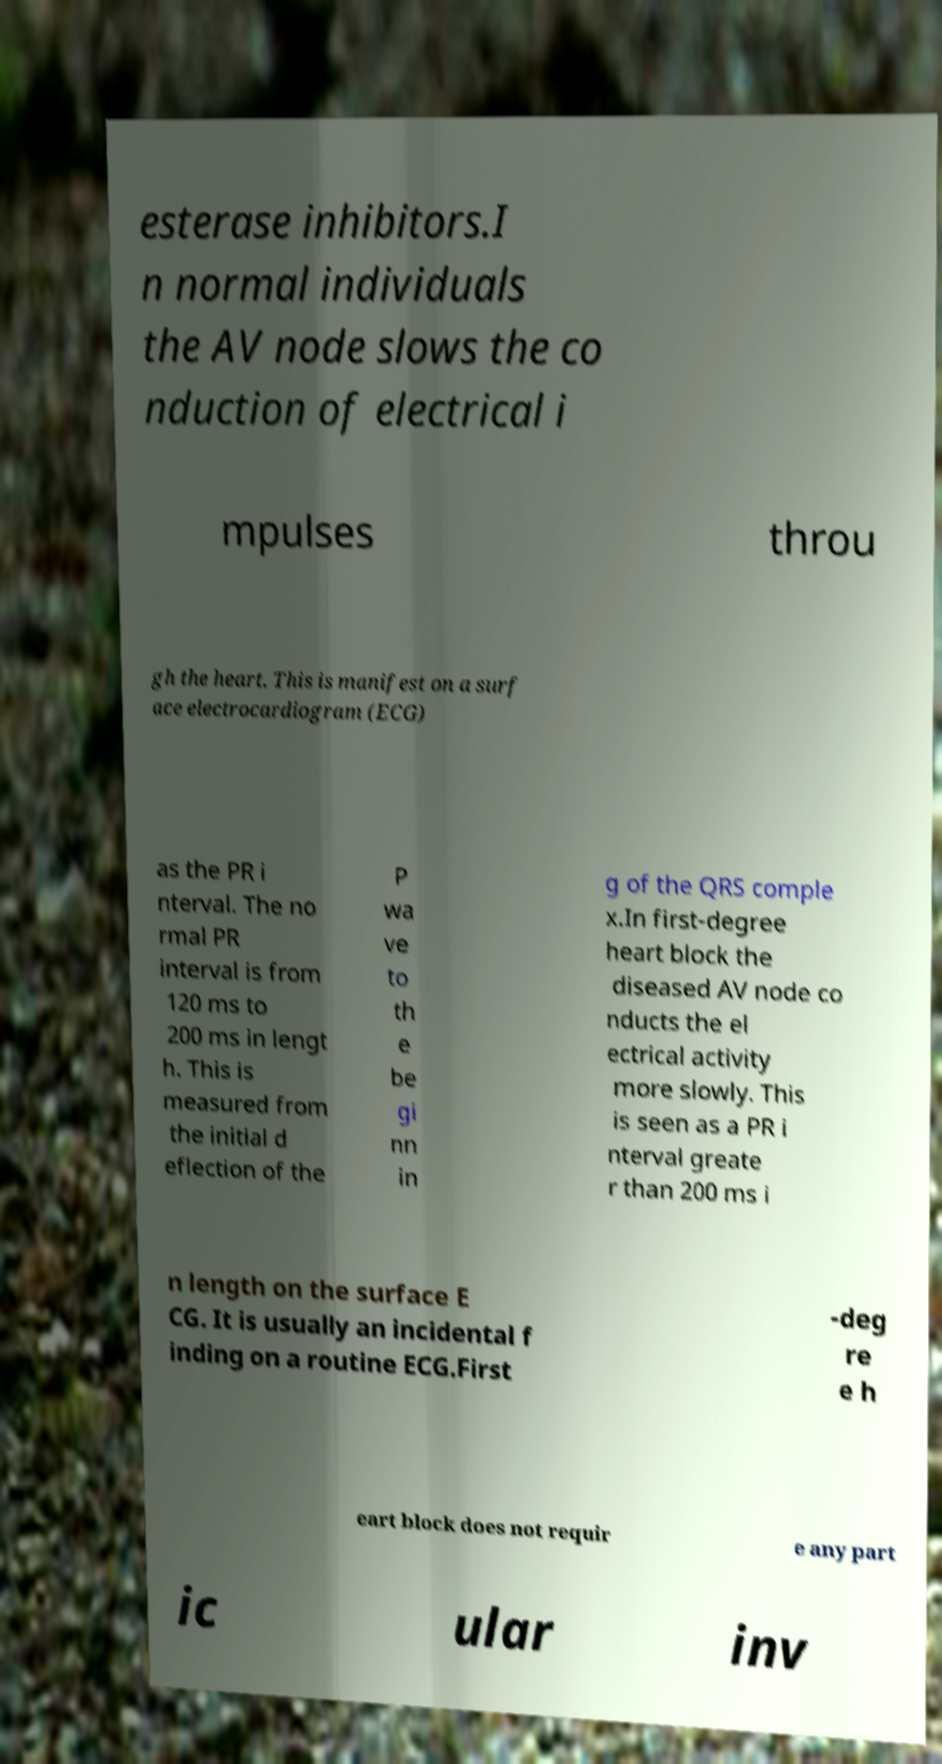What messages or text are displayed in this image? I need them in a readable, typed format. esterase inhibitors.I n normal individuals the AV node slows the co nduction of electrical i mpulses throu gh the heart. This is manifest on a surf ace electrocardiogram (ECG) as the PR i nterval. The no rmal PR interval is from 120 ms to 200 ms in lengt h. This is measured from the initial d eflection of the P wa ve to th e be gi nn in g of the QRS comple x.In first-degree heart block the diseased AV node co nducts the el ectrical activity more slowly. This is seen as a PR i nterval greate r than 200 ms i n length on the surface E CG. It is usually an incidental f inding on a routine ECG.First -deg re e h eart block does not requir e any part ic ular inv 